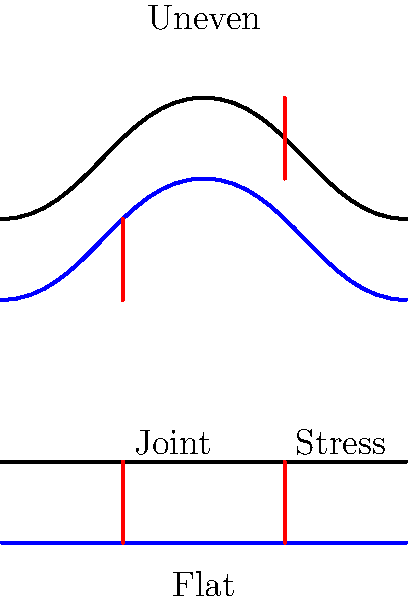Based on the skeletal diagram comparing walking on flat farmland versus uneven terrain, which scenario is likely to result in higher joint stress for a farmer working long hours in the field? To determine which scenario results in higher joint stress, we need to consider the biomechanics of walking on different surfaces:

1. Flat farmland:
   - Consistent surface allows for uniform gait
   - Weight distribution is even between joints
   - Muscles work in a predictable pattern

2. Uneven terrain:
   - Irregular surface requires constant adjustments in gait
   - Weight distribution varies with each step
   - Muscles work harder to maintain balance and stability

3. Joint stress factors:
   - Uneven surfaces increase the range of motion in joints
   - More force is required to stabilize the body on uneven ground
   - Risk of sudden movements or missteps is higher on uneven terrain

4. Long-term effects:
   - Prolonged walking on uneven terrain leads to increased fatigue
   - Fatigue can result in poor posture and improper joint alignment
   - Repetitive stress on misaligned joints increases overall joint stress

5. Farming context:
   - Farmers often work long hours, exacerbating the effects of uneven terrain
   - Carrying tools or harvested crops adds extra weight, increasing joint stress
   - Uneven terrain is more common in rural farming areas than perfectly flat surfaces

Considering these factors, walking on uneven terrain is likely to result in higher joint stress for a farmer working long hours in the field.
Answer: Uneven terrain 